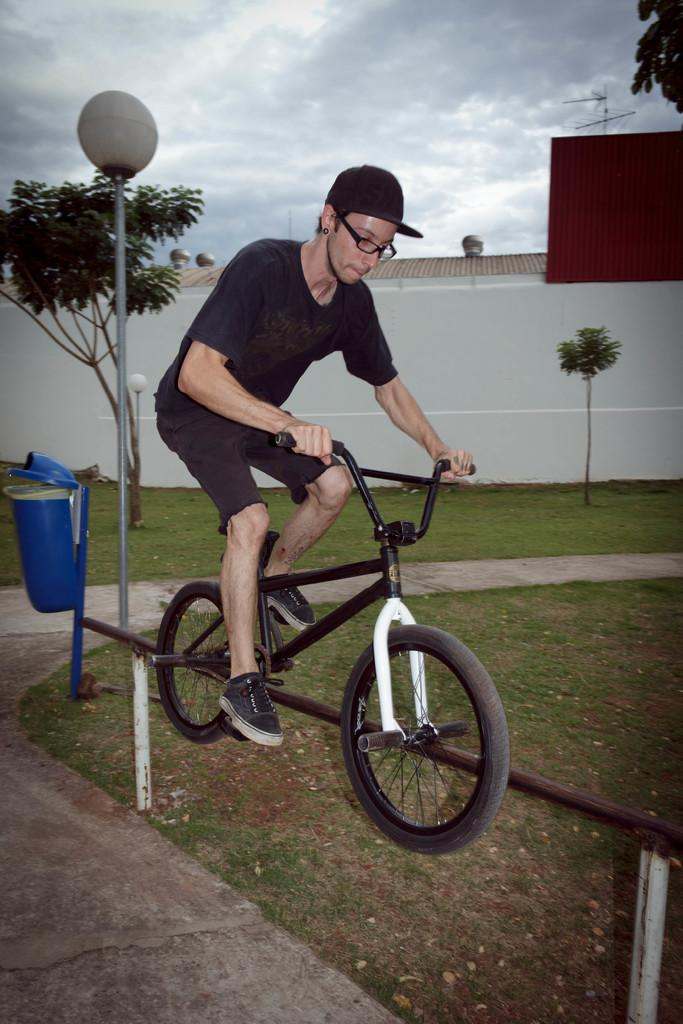What is the man doing in the image? The man is riding a cycle in the image. How is the cycle connected to the environment? The cycle is attached to a road in the image. What object can be seen behind the road? There is a dustbin behind the road in the image. What can be seen in the background of the image? There is a small tree and a wall in the background of the image. What type of haircut does the man have while riding the cycle? There is no information about the man's haircut in the image, as the focus is on his activity of riding a cycle. 